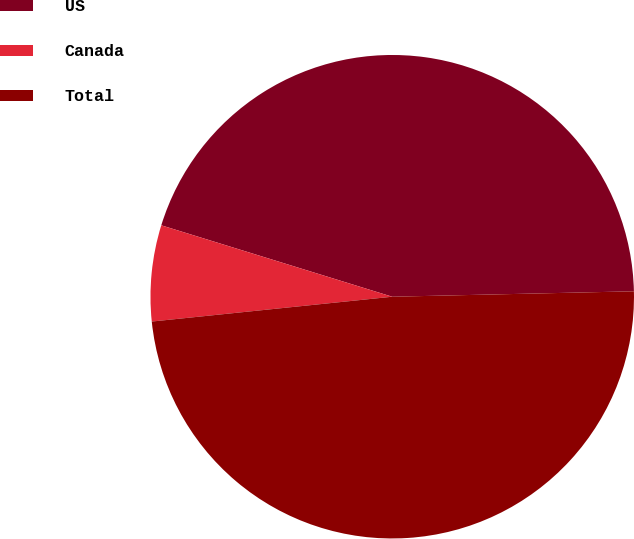<chart> <loc_0><loc_0><loc_500><loc_500><pie_chart><fcel>US<fcel>Canada<fcel>Total<nl><fcel>44.87%<fcel>6.41%<fcel>48.72%<nl></chart> 